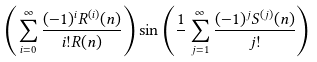Convert formula to latex. <formula><loc_0><loc_0><loc_500><loc_500>\left ( \sum _ { i = 0 } ^ { \infty } \frac { ( - 1 ) ^ { i } R ^ { ( i ) } ( n ) } { i ! R ( n ) } \right ) \sin \left ( \frac { 1 } { } \sum _ { j = 1 } ^ { \infty } \frac { ( - 1 ) ^ { j } S ^ { ( j ) } ( n ) } { j ! } \right )</formula> 